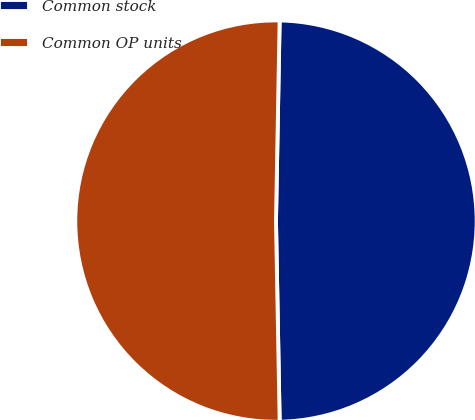Convert chart. <chart><loc_0><loc_0><loc_500><loc_500><pie_chart><fcel>Common stock<fcel>Common OP units<nl><fcel>49.42%<fcel>50.58%<nl></chart> 